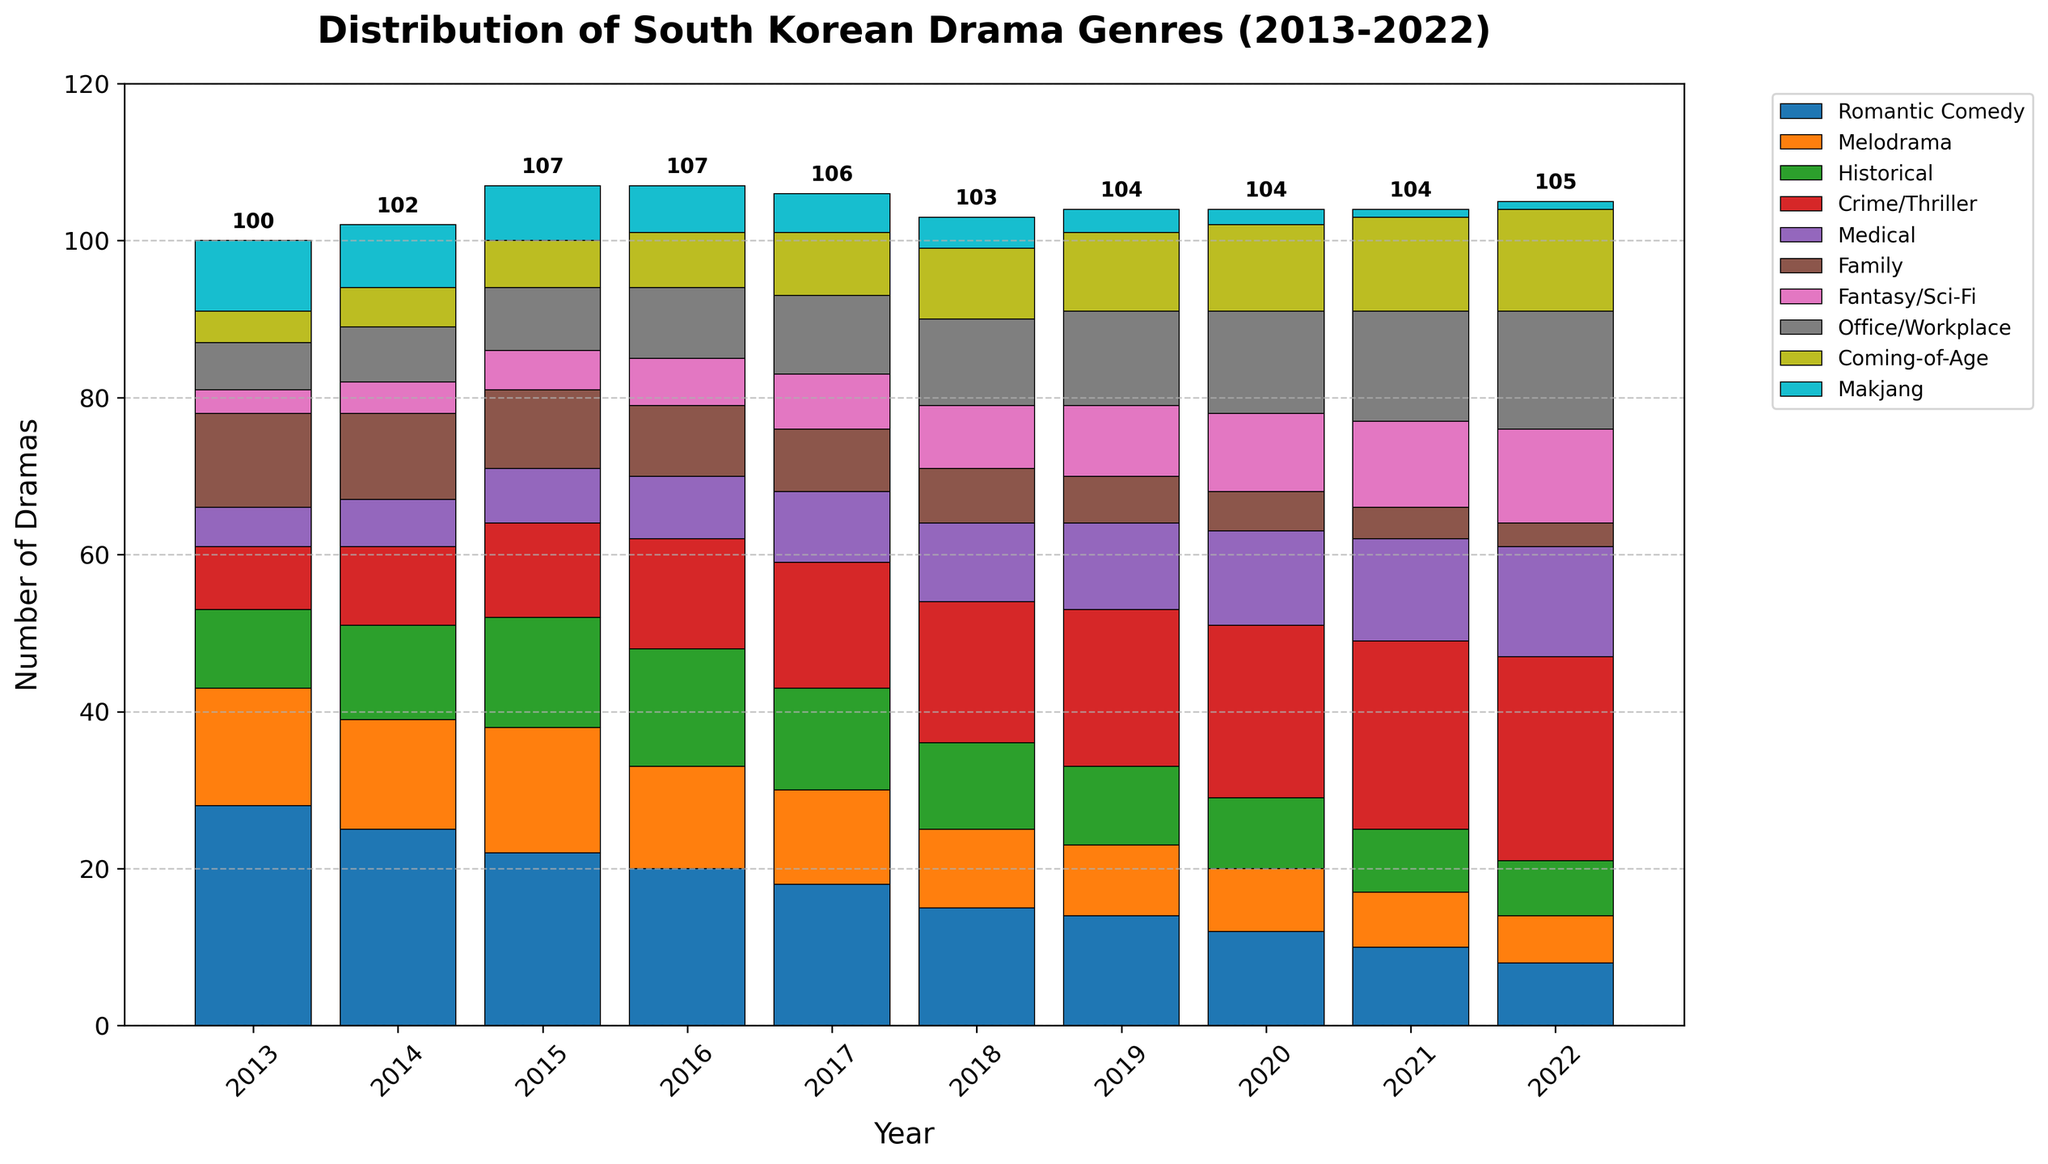What genre experienced the largest growth in the number of dramas from 2013 to 2022? Compare the number of Crime/Thriller dramas in 2013 and 2022. In 2013, there were 8, and in 2022, there were 26. The difference is 26 - 8 = 18, which is the largest growth among all genres.
Answer: Crime/Thriller What was the total number of Romantic Comedies and Family dramas in 2013? Sum the number of Romantic Comedies and Family dramas in 2013. Romantic Comedies in 2013 were 28, and Family dramas were 12. The total is 28 + 12 = 40.
Answer: 40 Which genre had the fewest dramas in 2022 and how many? Review the bars for each genre in 2022. Makjang has the smallest bar with a count of 1.
Answer: Makjang, 1 How many genres saw a decrease in the number of dramas from 2013 to 2022? Count the genres in the chart where the bar for 2022 is lower than for 2013. Romantic Comedy, Melodrama, Historical, Family, Makjang each have decreased. Thus, 5 genres have seen a decrease.
Answer: 5 By how much did the number of Medical dramas increase from 2013 to 2022? Check the number of Medical dramas in 2013 and 2022. In 2013, there were 5, and in 2022, there were 14. The increase is 14 - 5 = 9.
Answer: 9 Which genre had the highest number of dramas in 2013 and what was the count? Identify the genre with the tallest bar for the year 2013. Romantic Comedy has the highest number of 28.
Answer: Romantic Comedy, 28 How many genres had an equal or greater number of dramas than Melodrama in 2022? Look at the number of dramas for Melodrama in 2022 (6) and count the genres equal to or more than this. Crime/Thriller, Medical, Fantasy/Sci-Fi, Office/Workplace, and Coming-of-Age all have 6 or more. This makes 5 genres.
Answer: 5 What is the total number of Fantasy/Sci-Fi dramas produced between 2013 and 2022? Sum the number of Fantasy/Sci-Fi dramas each year from 2013 to 2022: 3 + 4 + 5 + 6 + 7 + 8 + 9 + 10 + 11 + 12 = 75.
Answer: 75 Which genre had the steadiest increase over the past decade? Review the trends for each genre and identify the one with a consistent increase each year. Crime/Thriller increases steadily each year from 8 in 2013 to 26 in 2022.
Answer: Crime/Thriller 